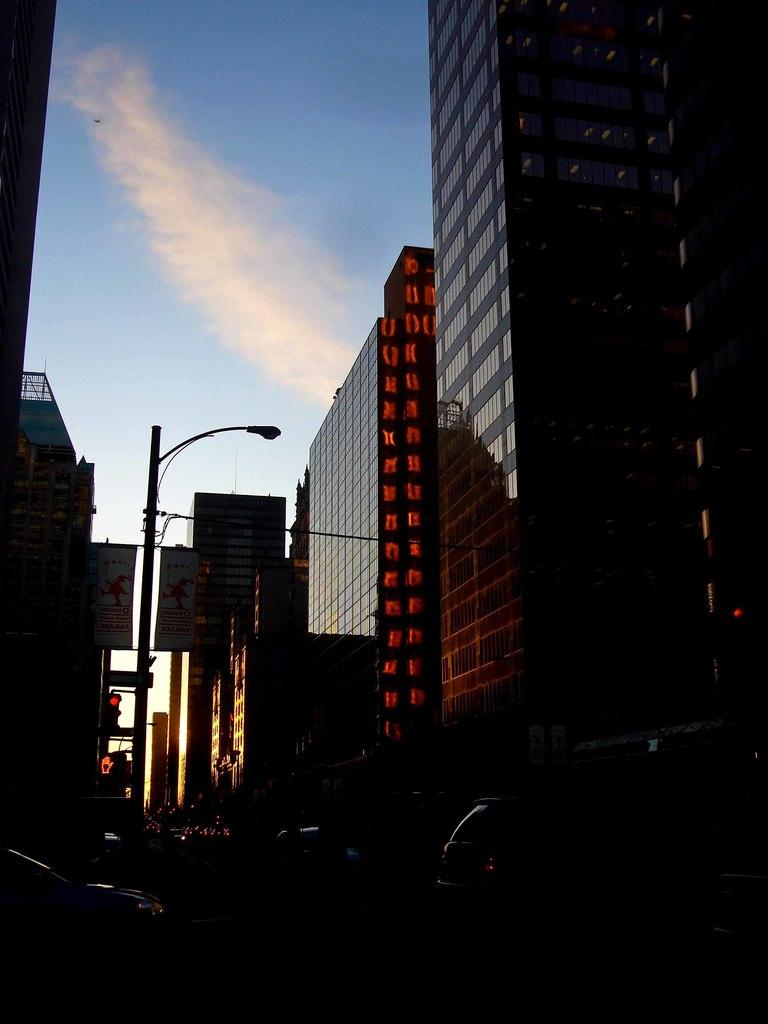What type of vehicles can be seen on the road in the image? There are motor vehicles on the road in the image. What structures are present along the road? Street poles, street lights, buildings, traffic poles, and traffic signals are visible in the image. What can be seen in the sky in the image? The sky is visible in the image, and clouds are present. Can you see a sail on any of the motor vehicles in the image? There is no sail present on any of the motor vehicles in the image. Is there a window visible in the image? The provided facts do not mention a window, so we cannot definitively say whether a window is present or not. --- Facts: 1. There is a person sitting on a bench. 2. The person is reading a book. 3. The bench is located in a park. 4. There are trees in the park. 5. There is a playground in the park. 6. The sky is visible in the image. Absurd Topics: parrot, bicycle, ocean Conversation: What is the person in the image doing? The person is sitting on a bench and reading a book. Where is the bench located? The bench is located in a park. What can be seen in the park besides the bench? There are trees and a playground in the park. What is visible in the sky in the image? The sky is visible in the image. Reasoning: Let's think step by step in order to produce the conversation. We start by identifying the main subject in the image, which is the person sitting on the bench. Then, we expand the conversation to include other items that are also visible, such as the book, the park, trees, and the playground. Each question is designed to elicit a specific detail about the image that is known from the provided facts. Absurd Question/Answer: Can you see a parrot sitting on the person's shoulder in the image? There is no parrot present on the person's shoulder in the image. Is there a bicycle visible in the image? The provided facts do not mention a bicycle, so we cannot definitively say whether a bicycle is present or not. 